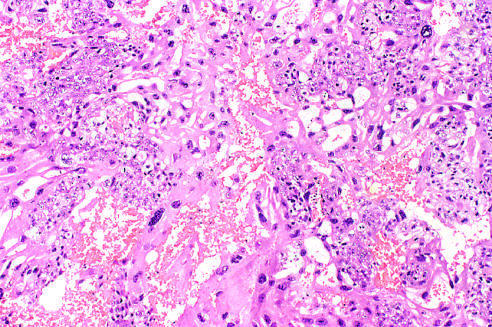does the high-power detail of an asbestos body contain both neoplastic cytotro-phoblast and multinucleate syncytiotrophoblast?
Answer the question using a single word or phrase. No 